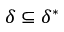<formula> <loc_0><loc_0><loc_500><loc_500>\delta \subseteq \delta ^ { * }</formula> 